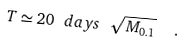Convert formula to latex. <formula><loc_0><loc_0><loc_500><loc_500>T \simeq 2 0 \ d a y s \ \sqrt { M _ { 0 . 1 } } \ \ .</formula> 